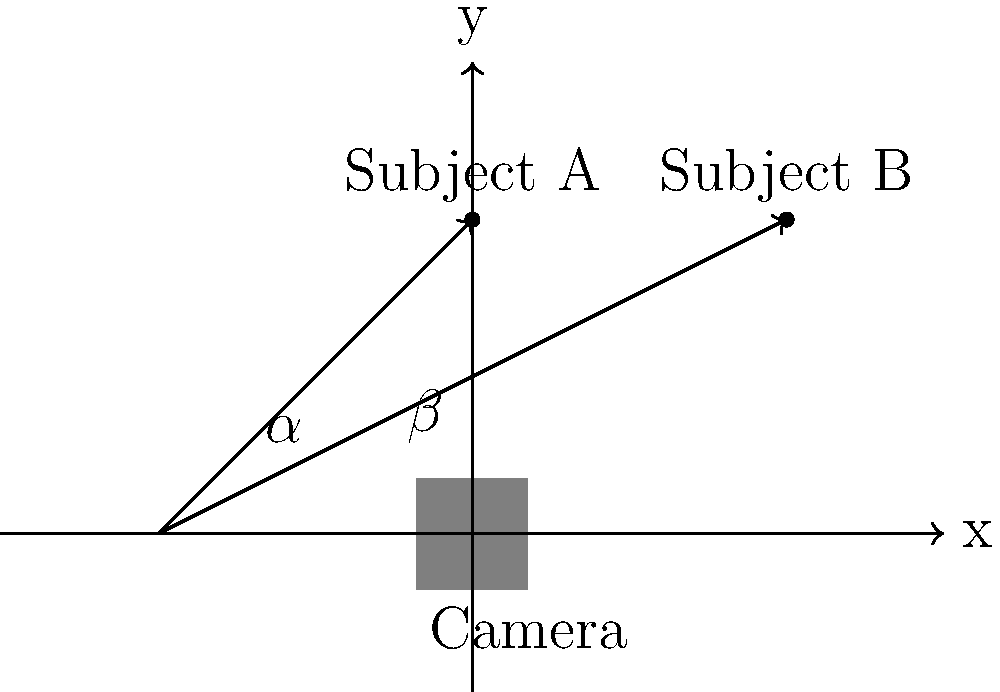In the diagram above, two subjects (A and B) are being filmed. The camera's field of view is represented by the angles $\alpha$ and $\beta$. Which type of shot does this setup most likely represent, and how would adjusting the camera's position affect the composition? To answer this question, let's analyze the diagram step-by-step:

1. Camera position: The camera is placed at the origin (0,0) of the coordinate system.

2. Subject positions: 
   - Subject A is positioned at (0,2)
   - Subject B is positioned at (2,2)

3. Camera angles:
   - $\alpha$ represents the angle between the x-axis and the line to Subject A
   - $\beta$ represents the angle between the x-axis and the line to Subject B

4. Shot analysis:
   - Both subjects are in frame, with some space between them
   - The camera is positioned to capture both subjects from a slight angle

5. Shot identification:
   This setup most closely resembles a medium two-shot or a wide two-shot, depending on how much of the subjects' bodies are in frame.

6. Camera position effects:
   - Moving closer (along positive y-axis): This would create a tighter two-shot, potentially becoming a medium close-up of both subjects.
   - Moving back (along negative y-axis): This would widen the shot, potentially becoming a full shot or long shot of both subjects.
   - Moving left (along negative x-axis): This would create a more profile view of Subject A and a more frontal view of Subject B.
   - Moving right (along positive x-axis): This would create a more frontal view of Subject A and a more profile view of Subject B.

7. Compositional impact:
   - Adjusting the camera's position would affect the perceived relationship between the subjects and their environment.
   - It would also change the emotional impact of the shot, with closer shots generally creating more intimacy and wider shots establishing context.
Answer: Medium/wide two-shot; moving camera affects subject framing, angle, and emotional impact. 